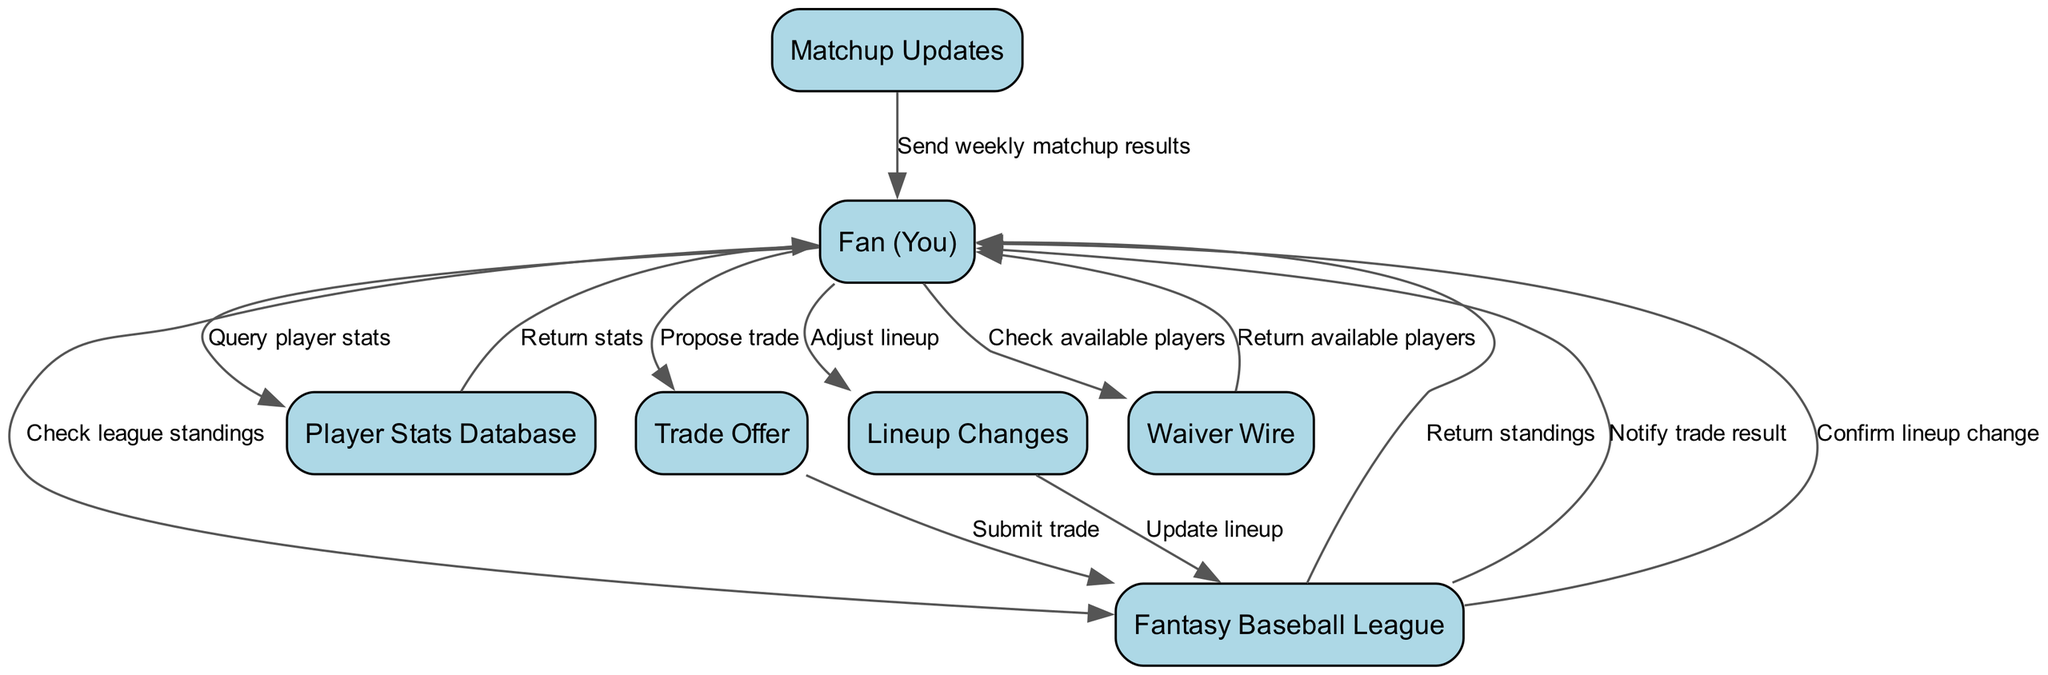What is the total number of nodes in the diagram? The nodes represent different entities involved in the fantasy baseball interactions. By counting the elements listed, there are a total of seven nodes: Fan (You), Fantasy Baseball League, Player Stats Database, Trade Offer, Lineup Changes, Matchup Updates, and Waiver Wire.
Answer: 7 What actions does the Fan (You) take towards the Fantasy Baseball League? The Fan (You) interacts with the Fantasy Baseball League in two ways: first by checking the league standings, and second by adjusting the lineup, which involves updating the lineup through the Fantasy Baseball League.
Answer: Check league standings; Adjust lineup How many interactions are related to trades? The diagram illustrates three key interactions pertaining to trades: proposing a trade to the Trade Offer, submitting the trade to the Fantasy Baseball League, and receiving a notification about the trade result.
Answer: 3 Which entity does the Fan (You) query to return player stats? The Fan (You) queries the Player Stats Database to obtain the statistics of players. The edge in the diagram directly shows the interaction leading from the Fan (You) to the Player Stats Database.
Answer: Player Stats Database How does the Fan (You) learn about weekly matchup results? The Fan (You) receives notifications about weekly matchup results from the Matchup Updates node. This indicates a clear direction of information flow from Matchup Updates to the Fan (You).
Answer: Matchup Updates What is the purpose of the Waiver Wire in the diagram? The Waiver Wire consists of available players who are not currently on any team roster. The Fan (You) checks the Waiver Wire to discover these players. This is reflected in the edge connecting the Waiver Wire back to the Fan (You).
Answer: Available players What happens after the Fan (You) adjusts the lineup? After the Fan (You) makes adjustments to the lineup, the lineup change is updated in the Fantasy Baseball League, which then confirms the changes back to the Fan (You). This follows the sequence shown in the diagram.
Answer: Confirm lineup change How many edges originate from the Fan (You)? By reviewing the diagram, the Fan (You) initiates actions that lead to six edges, each connecting to different entities for various interactions such as checking stats, proposing trades, adjusting lineups, and more.
Answer: 6 